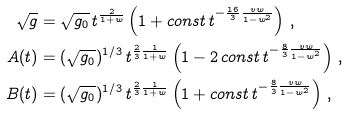Convert formula to latex. <formula><loc_0><loc_0><loc_500><loc_500>\sqrt { g } & = \sqrt { g _ { 0 } } \, t ^ { \frac { 2 } { 1 + w } } \left ( 1 + c o n s t \, t ^ { - \frac { 1 6 } { 3 } \frac { v w } { 1 - w ^ { 2 } } } \right ) \, , \\ A ( t ) & = ( \sqrt { g _ { 0 } } ) ^ { 1 / 3 } \, t ^ { \frac { 2 } { 3 } \frac { 1 } { 1 + w } } \left ( 1 - 2 \, c o n s t \, t ^ { - \frac { 8 } { 3 } \frac { v w } { 1 - w ^ { 2 } } } \right ) \, , \\ B ( t ) & = ( \sqrt { g _ { 0 } } ) ^ { 1 / 3 } \, t ^ { \frac { 2 } { 3 } \frac { 1 } { 1 + w } } \left ( 1 + c o n s t \, t ^ { - \frac { 8 } { 3 } \frac { v w } { 1 - w ^ { 2 } } } \right ) \, ,</formula> 